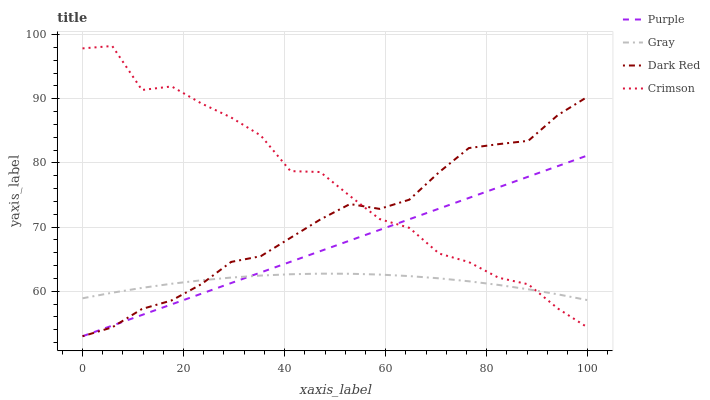Does Gray have the minimum area under the curve?
Answer yes or no. Yes. Does Crimson have the maximum area under the curve?
Answer yes or no. Yes. Does Crimson have the minimum area under the curve?
Answer yes or no. No. Does Gray have the maximum area under the curve?
Answer yes or no. No. Is Purple the smoothest?
Answer yes or no. Yes. Is Crimson the roughest?
Answer yes or no. Yes. Is Gray the smoothest?
Answer yes or no. No. Is Gray the roughest?
Answer yes or no. No. Does Purple have the lowest value?
Answer yes or no. Yes. Does Crimson have the lowest value?
Answer yes or no. No. Does Crimson have the highest value?
Answer yes or no. Yes. Does Gray have the highest value?
Answer yes or no. No. Does Purple intersect Gray?
Answer yes or no. Yes. Is Purple less than Gray?
Answer yes or no. No. Is Purple greater than Gray?
Answer yes or no. No. 